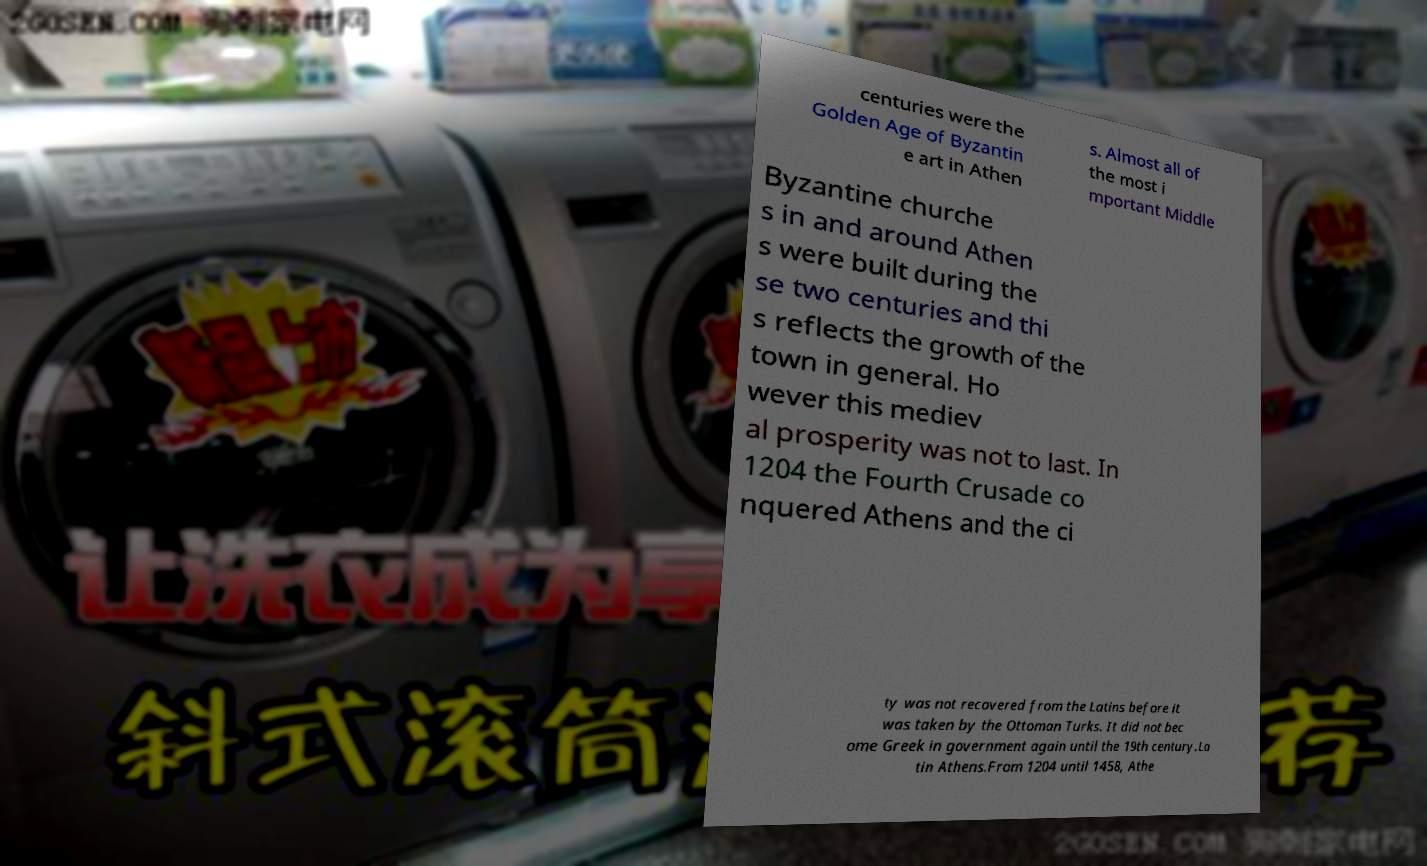Could you extract and type out the text from this image? centuries were the Golden Age of Byzantin e art in Athen s. Almost all of the most i mportant Middle Byzantine churche s in and around Athen s were built during the se two centuries and thi s reflects the growth of the town in general. Ho wever this mediev al prosperity was not to last. In 1204 the Fourth Crusade co nquered Athens and the ci ty was not recovered from the Latins before it was taken by the Ottoman Turks. It did not bec ome Greek in government again until the 19th century.La tin Athens.From 1204 until 1458, Athe 